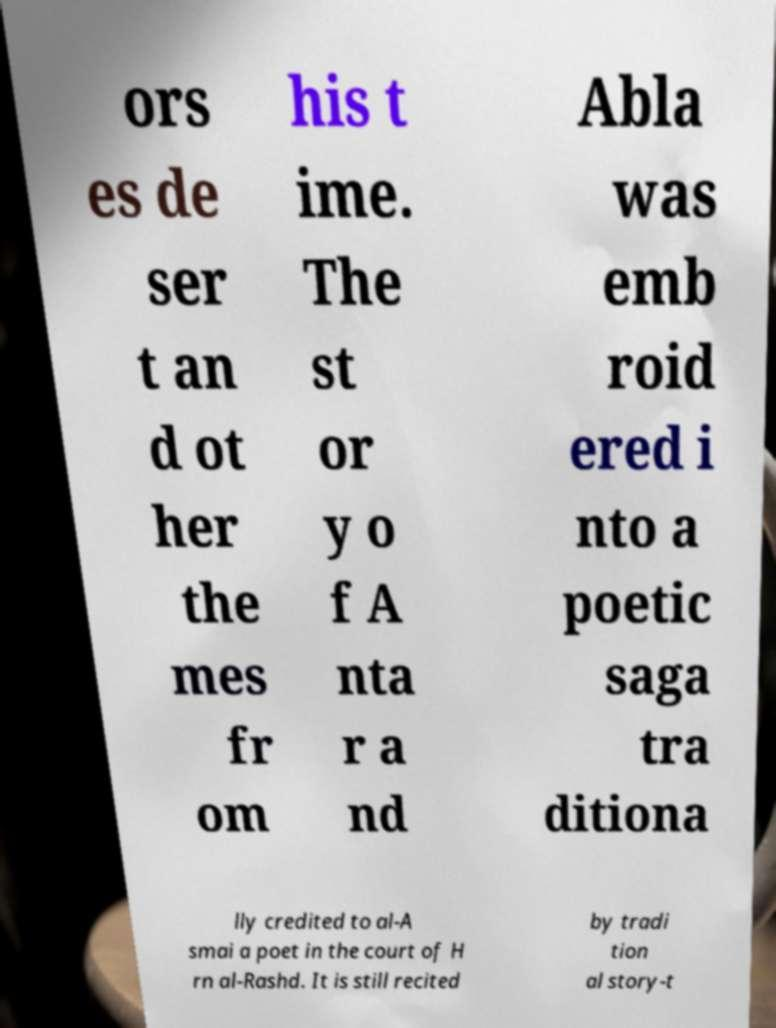For documentation purposes, I need the text within this image transcribed. Could you provide that? ors es de ser t an d ot her the mes fr om his t ime. The st or y o f A nta r a nd Abla was emb roid ered i nto a poetic saga tra ditiona lly credited to al-A smai a poet in the court of H rn al-Rashd. It is still recited by tradi tion al story-t 